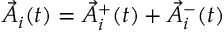<formula> <loc_0><loc_0><loc_500><loc_500>\vec { A } _ { i } ( t ) = \vec { A } _ { i } ^ { + } ( t ) + \vec { A } _ { i } ^ { - } ( t )</formula> 